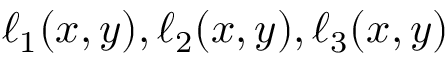<formula> <loc_0><loc_0><loc_500><loc_500>\ell _ { 1 } ( x , y ) , \ell _ { 2 } ( x , y ) , \ell _ { 3 } ( x , y )</formula> 